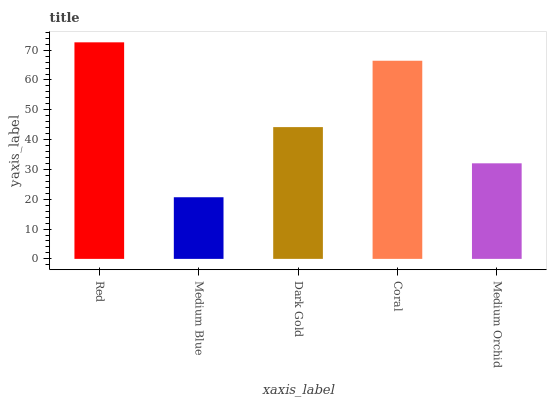Is Medium Blue the minimum?
Answer yes or no. Yes. Is Red the maximum?
Answer yes or no. Yes. Is Dark Gold the minimum?
Answer yes or no. No. Is Dark Gold the maximum?
Answer yes or no. No. Is Dark Gold greater than Medium Blue?
Answer yes or no. Yes. Is Medium Blue less than Dark Gold?
Answer yes or no. Yes. Is Medium Blue greater than Dark Gold?
Answer yes or no. No. Is Dark Gold less than Medium Blue?
Answer yes or no. No. Is Dark Gold the high median?
Answer yes or no. Yes. Is Dark Gold the low median?
Answer yes or no. Yes. Is Red the high median?
Answer yes or no. No. Is Medium Blue the low median?
Answer yes or no. No. 